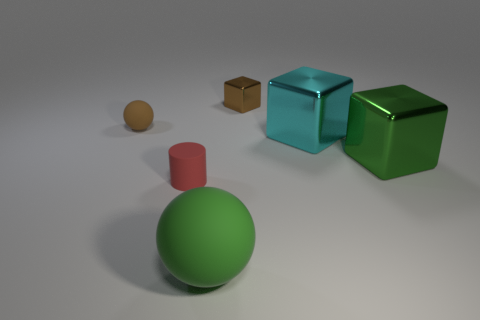Add 1 large cyan shiny cubes. How many objects exist? 7 Subtract all balls. How many objects are left? 4 Add 3 brown things. How many brown things exist? 5 Subtract 0 yellow balls. How many objects are left? 6 Subtract all brown things. Subtract all matte cylinders. How many objects are left? 3 Add 4 small red cylinders. How many small red cylinders are left? 5 